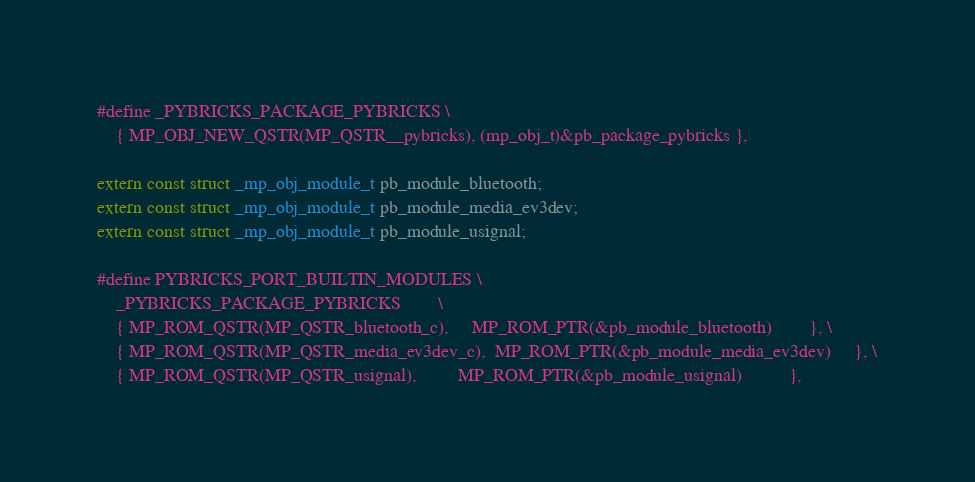Convert code to text. <code><loc_0><loc_0><loc_500><loc_500><_C_>#define _PYBRICKS_PACKAGE_PYBRICKS \
    { MP_OBJ_NEW_QSTR(MP_QSTR__pybricks), (mp_obj_t)&pb_package_pybricks },

extern const struct _mp_obj_module_t pb_module_bluetooth;
extern const struct _mp_obj_module_t pb_module_media_ev3dev;
extern const struct _mp_obj_module_t pb_module_usignal;

#define PYBRICKS_PORT_BUILTIN_MODULES \
    _PYBRICKS_PACKAGE_PYBRICKS        \
    { MP_ROM_QSTR(MP_QSTR_bluetooth_c),     MP_ROM_PTR(&pb_module_bluetooth)        }, \
    { MP_ROM_QSTR(MP_QSTR_media_ev3dev_c),  MP_ROM_PTR(&pb_module_media_ev3dev)     }, \
    { MP_ROM_QSTR(MP_QSTR_usignal),         MP_ROM_PTR(&pb_module_usignal)          },
</code> 